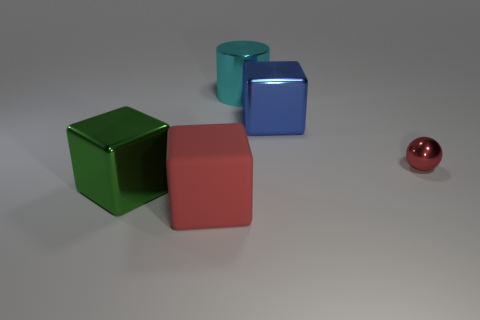Are there any cyan things of the same shape as the large blue object?
Your answer should be very brief. No. Do the cyan object that is on the right side of the big red block and the red thing to the right of the big blue object have the same shape?
Ensure brevity in your answer.  No. There is a large metallic object that is both to the left of the large blue metallic block and behind the small red shiny sphere; what shape is it?
Make the answer very short. Cylinder. Is there a yellow metal cube of the same size as the green thing?
Provide a succinct answer. No. There is a large rubber block; is it the same color as the large metallic thing that is in front of the large blue object?
Make the answer very short. No. What is the material of the green thing?
Provide a succinct answer. Metal. What is the color of the big metal cube that is in front of the blue metallic block?
Offer a terse response. Green. How many metal blocks are the same color as the ball?
Keep it short and to the point. 0. What number of large objects are behind the red matte block and on the left side of the cyan shiny thing?
Make the answer very short. 1. There is a red rubber object that is the same size as the blue metal thing; what is its shape?
Provide a short and direct response. Cube. 